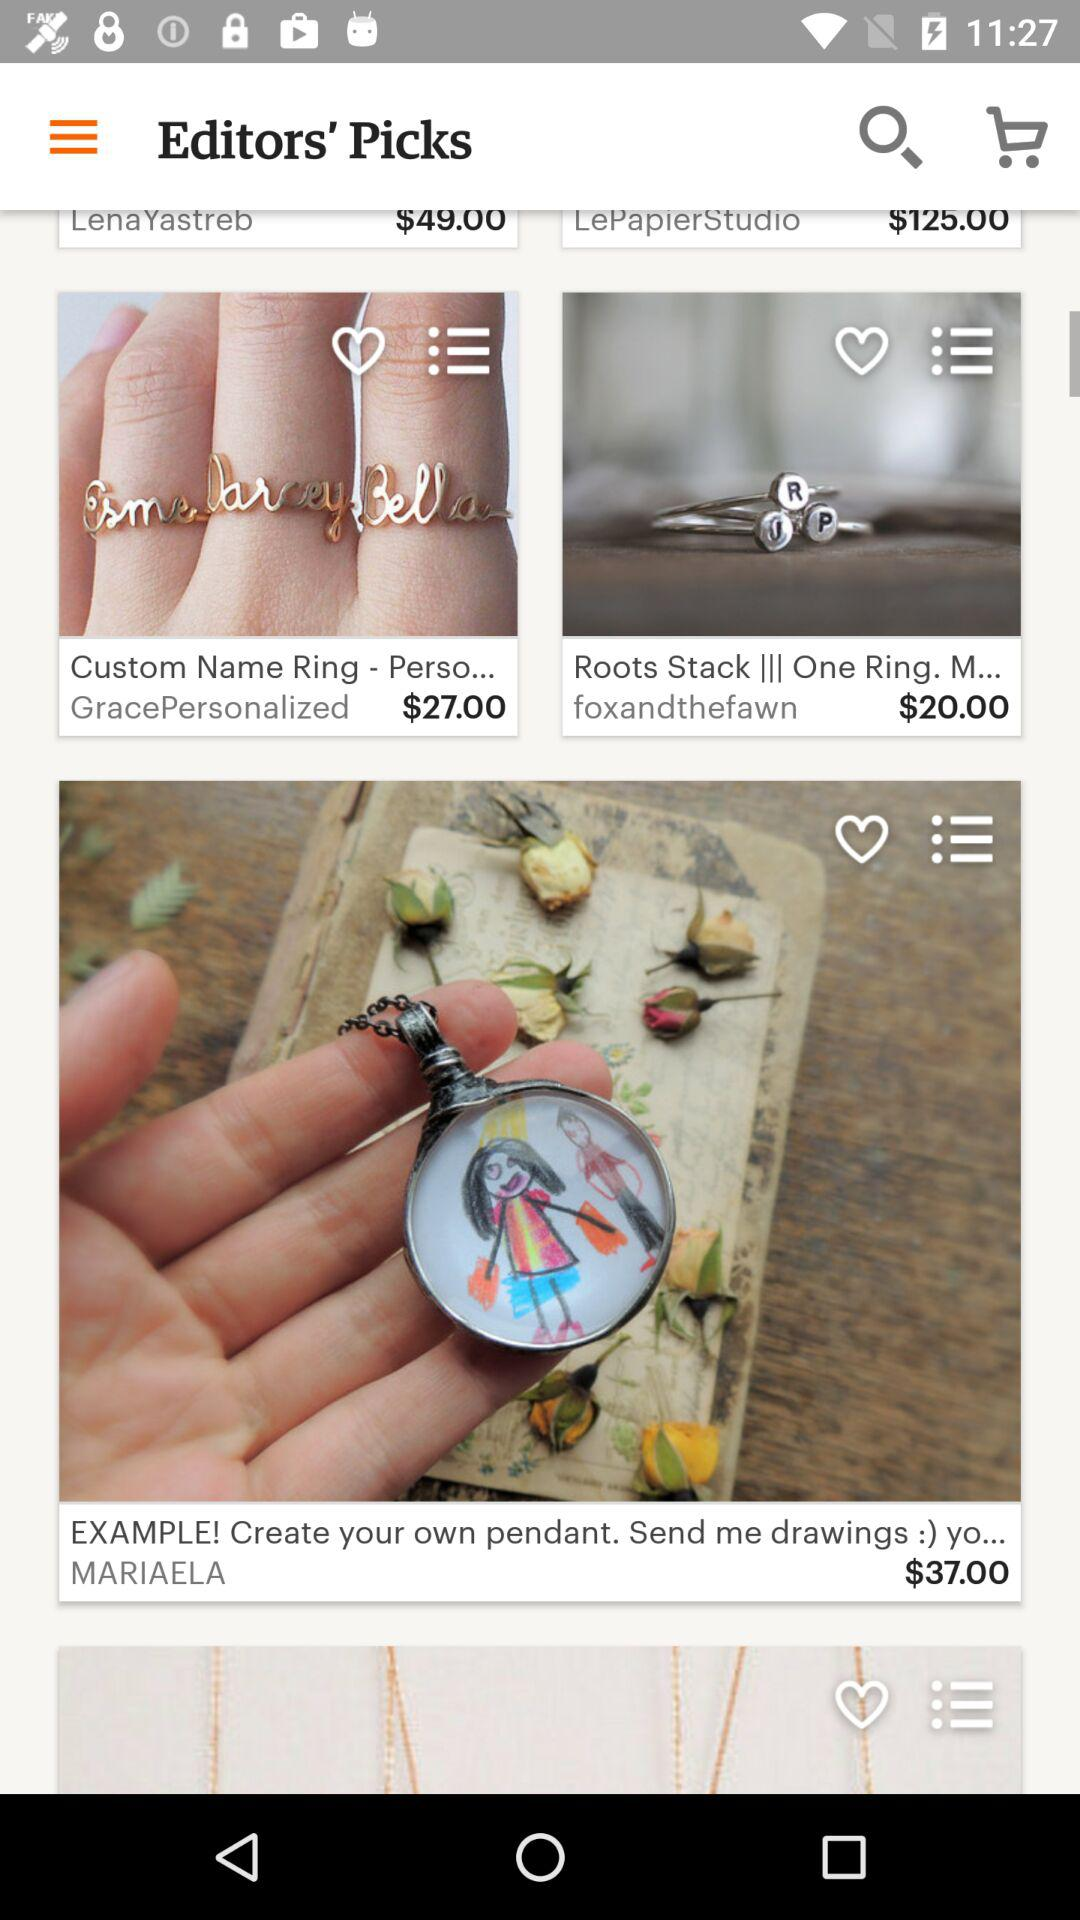What is the price of the pendant? The price of the pendant is $37. 